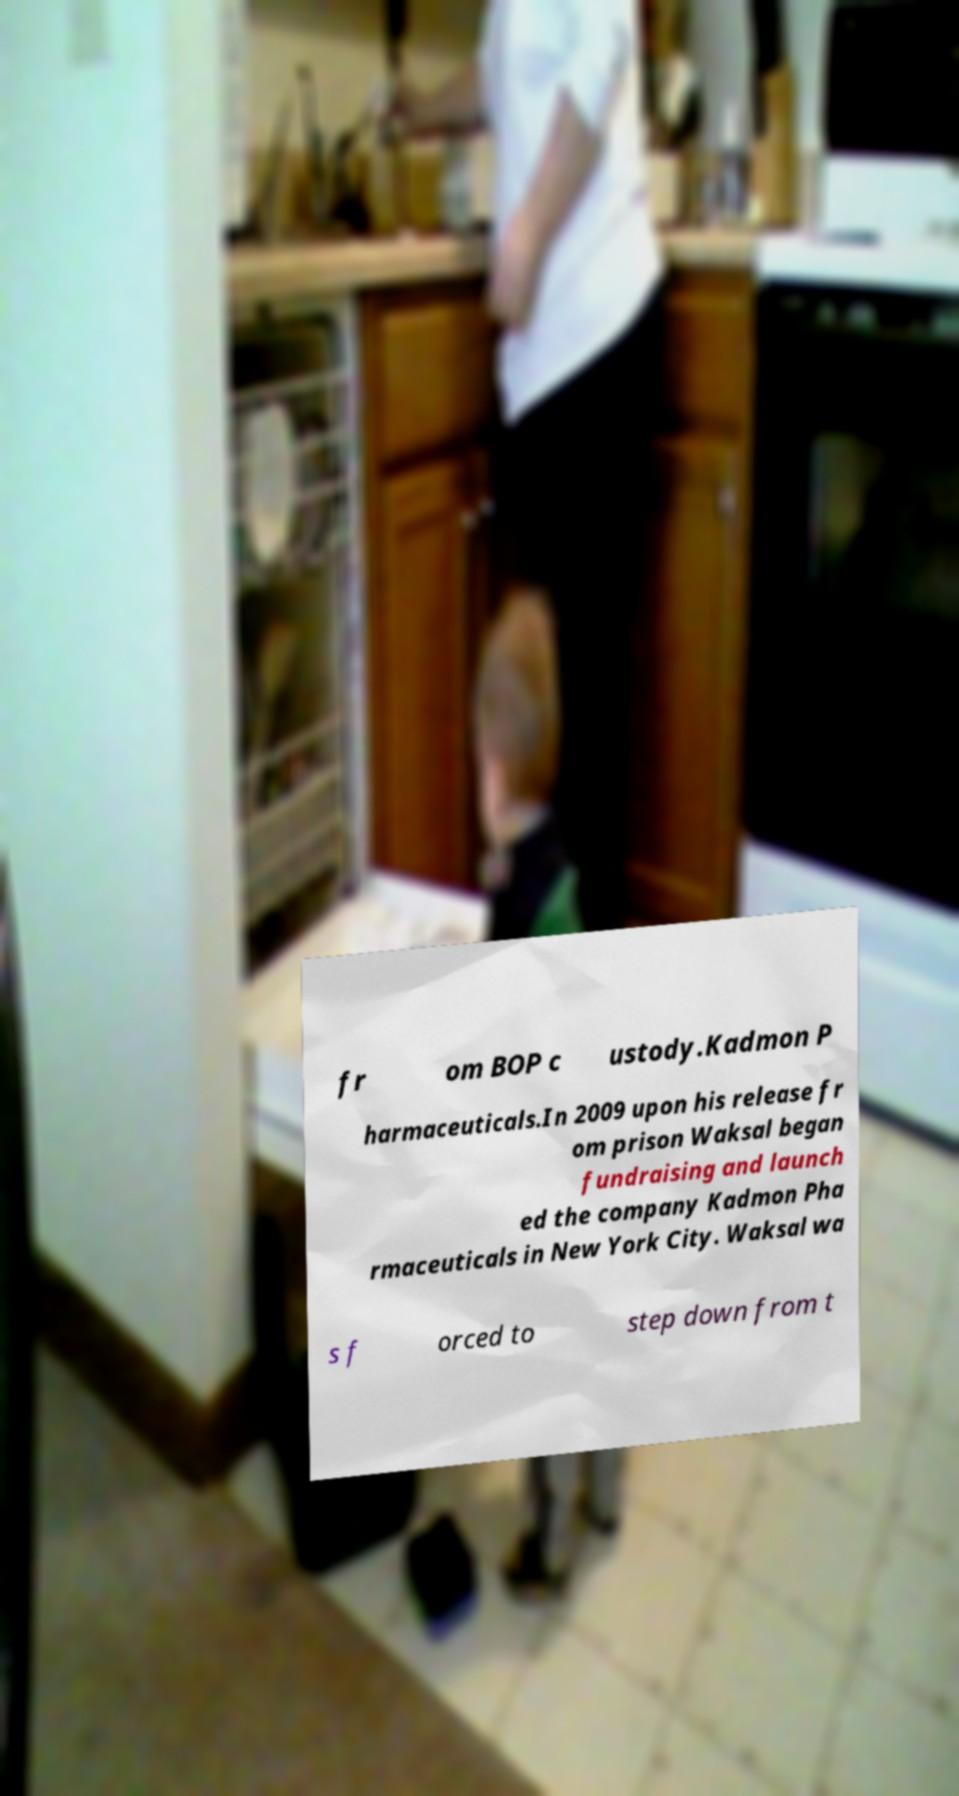I need the written content from this picture converted into text. Can you do that? fr om BOP c ustody.Kadmon P harmaceuticals.In 2009 upon his release fr om prison Waksal began fundraising and launch ed the company Kadmon Pha rmaceuticals in New York City. Waksal wa s f orced to step down from t 